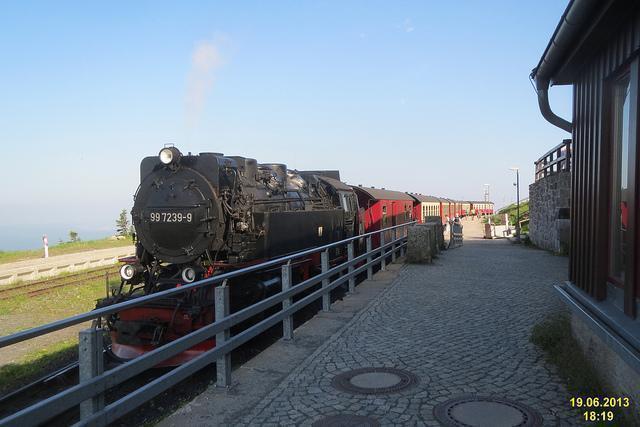Where might someone buy a ticket for this train?
From the following set of four choices, select the accurate answer to respond to the question.
Options: Online, newsboy, inside building, train. Inside building. 